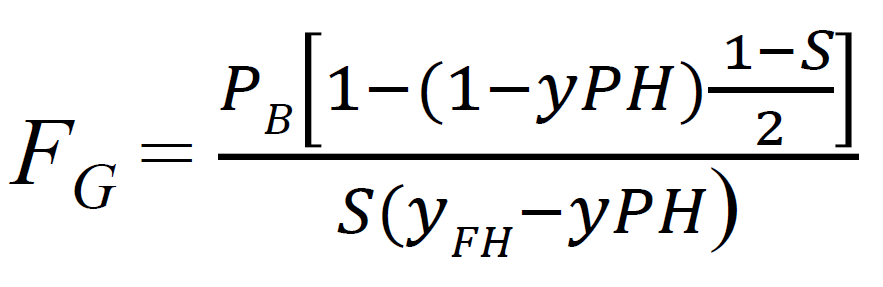latex inline format. text box to copy The equation provided in the image can be translated into LaTeX inline format as follows:

```
F_G = \frac{P_B \left[1 - \left(1 - yP_H\right)^{\frac{1 - S}{2}}\right]}{S(y - yP_H)}
```

You can copy and paste this into a LaTeX document or a compatible editor to render the equation as displayed in the image. 